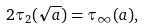Convert formula to latex. <formula><loc_0><loc_0><loc_500><loc_500>2 \tau _ { 2 } ( \sqrt { a } ) = \tau _ { \infty } ( a ) ,</formula> 